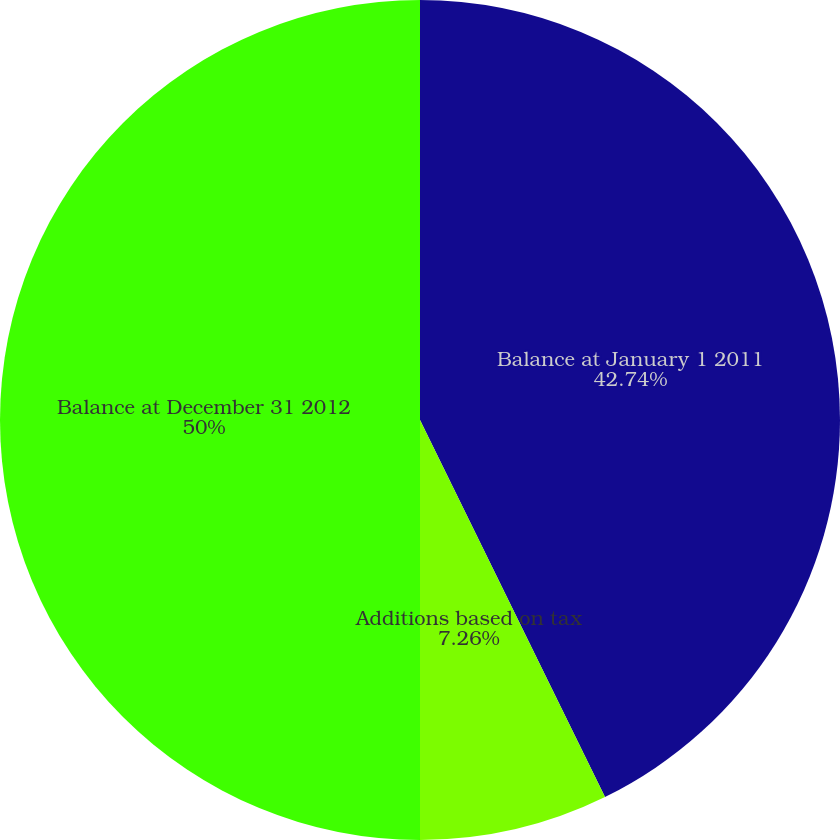Convert chart to OTSL. <chart><loc_0><loc_0><loc_500><loc_500><pie_chart><fcel>Balance at January 1 2011<fcel>Additions based on tax<fcel>Balance at December 31 2012<nl><fcel>42.74%<fcel>7.26%<fcel>50.0%<nl></chart> 